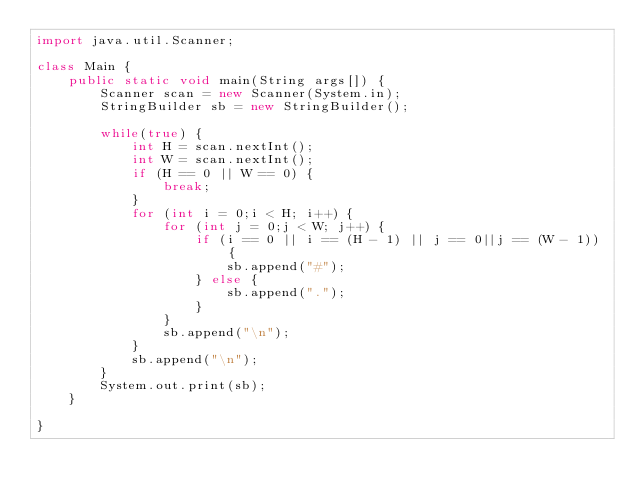<code> <loc_0><loc_0><loc_500><loc_500><_Java_>import java.util.Scanner;

class Main {
    public static void main(String args[]) {
        Scanner scan = new Scanner(System.in);
        StringBuilder sb = new StringBuilder();

        while(true) {
            int H = scan.nextInt();
            int W = scan.nextInt();
            if (H == 0 || W == 0) {
                break;
            }
            for (int i = 0;i < H; i++) {
                for (int j = 0;j < W; j++) {
                    if (i == 0 || i == (H - 1) || j == 0||j == (W - 1)) {
                        sb.append("#");
                    } else {
                        sb.append(".");
                    }
                }
                sb.append("\n");
            }
            sb.append("\n");
        }
        System.out.print(sb);
    }

}</code> 